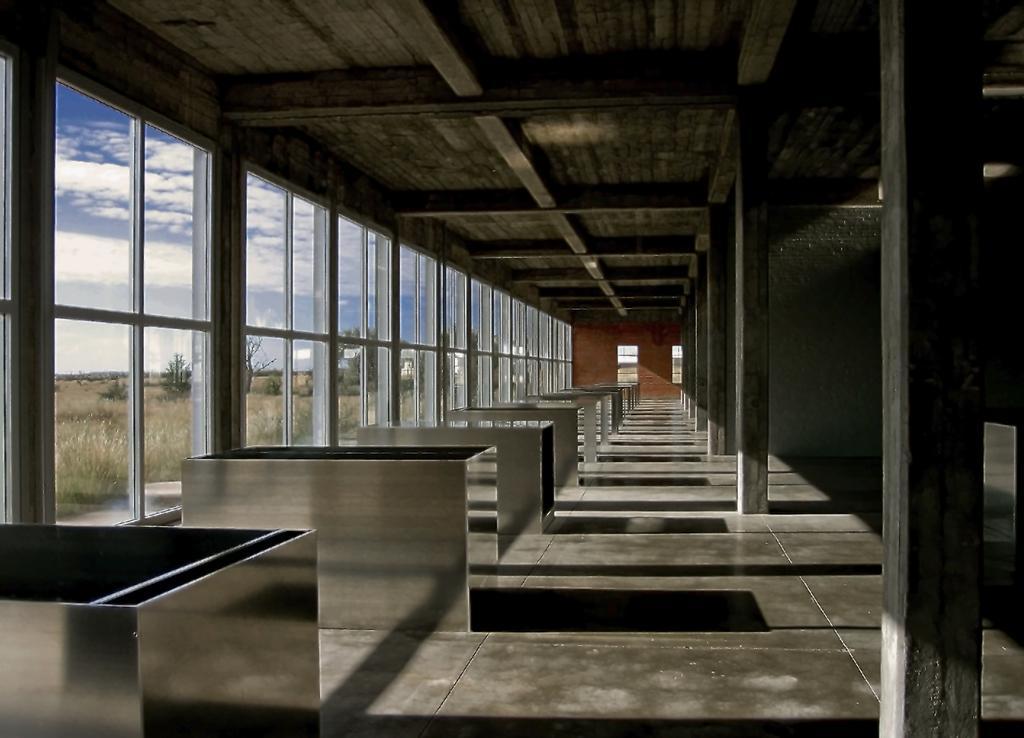How would you summarize this image in a sentence or two? In this picture we can see a shed, here we can see some objects on the ground, here we can see a wall, pillars, glass doors, roof and in the background we can see trees, plants and sky with clouds. 